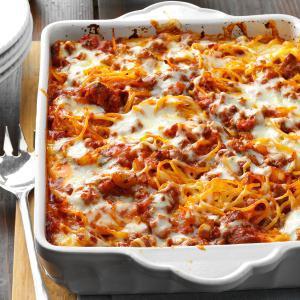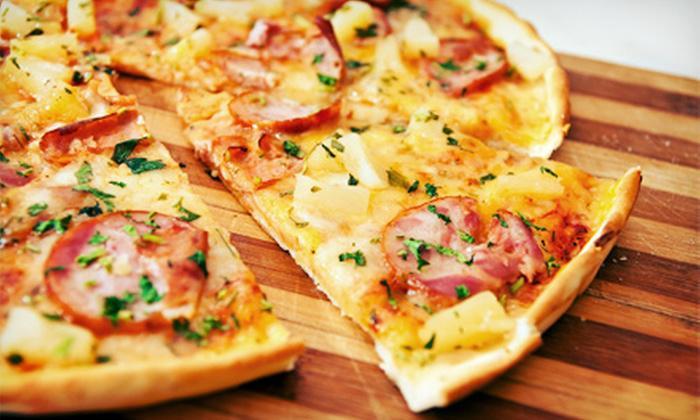The first image is the image on the left, the second image is the image on the right. For the images shown, is this caption "The left image shows a casserole in a rectangular white dish with a piece of silverware lying next to it on the left." true? Answer yes or no. Yes. The first image is the image on the left, the second image is the image on the right. For the images displayed, is the sentence "The food in the image on the left is sitting in a white square casserole dish." factually correct? Answer yes or no. Yes. 